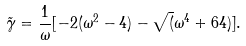Convert formula to latex. <formula><loc_0><loc_0><loc_500><loc_500>\tilde { \gamma } = \frac { 1 } { \omega } [ - 2 ( \omega ^ { 2 } - 4 ) - \sqrt { ( } \omega ^ { 4 } + 6 4 ) ] .</formula> 